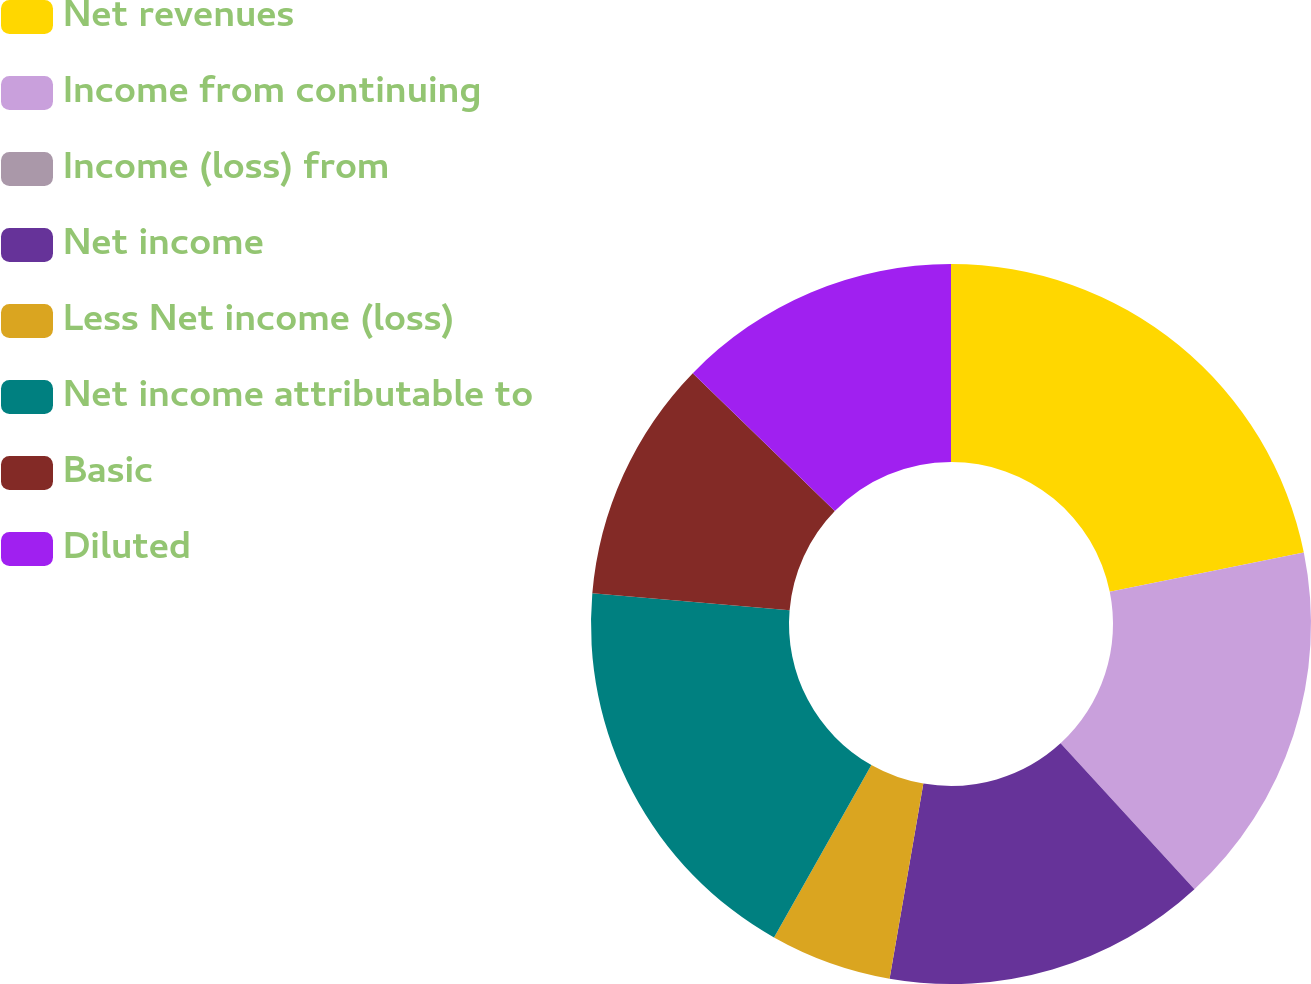Convert chart to OTSL. <chart><loc_0><loc_0><loc_500><loc_500><pie_chart><fcel>Net revenues<fcel>Income from continuing<fcel>Income (loss) from<fcel>Net income<fcel>Less Net income (loss)<fcel>Net income attributable to<fcel>Basic<fcel>Diluted<nl><fcel>21.82%<fcel>16.36%<fcel>0.0%<fcel>14.55%<fcel>5.45%<fcel>18.18%<fcel>10.91%<fcel>12.73%<nl></chart> 